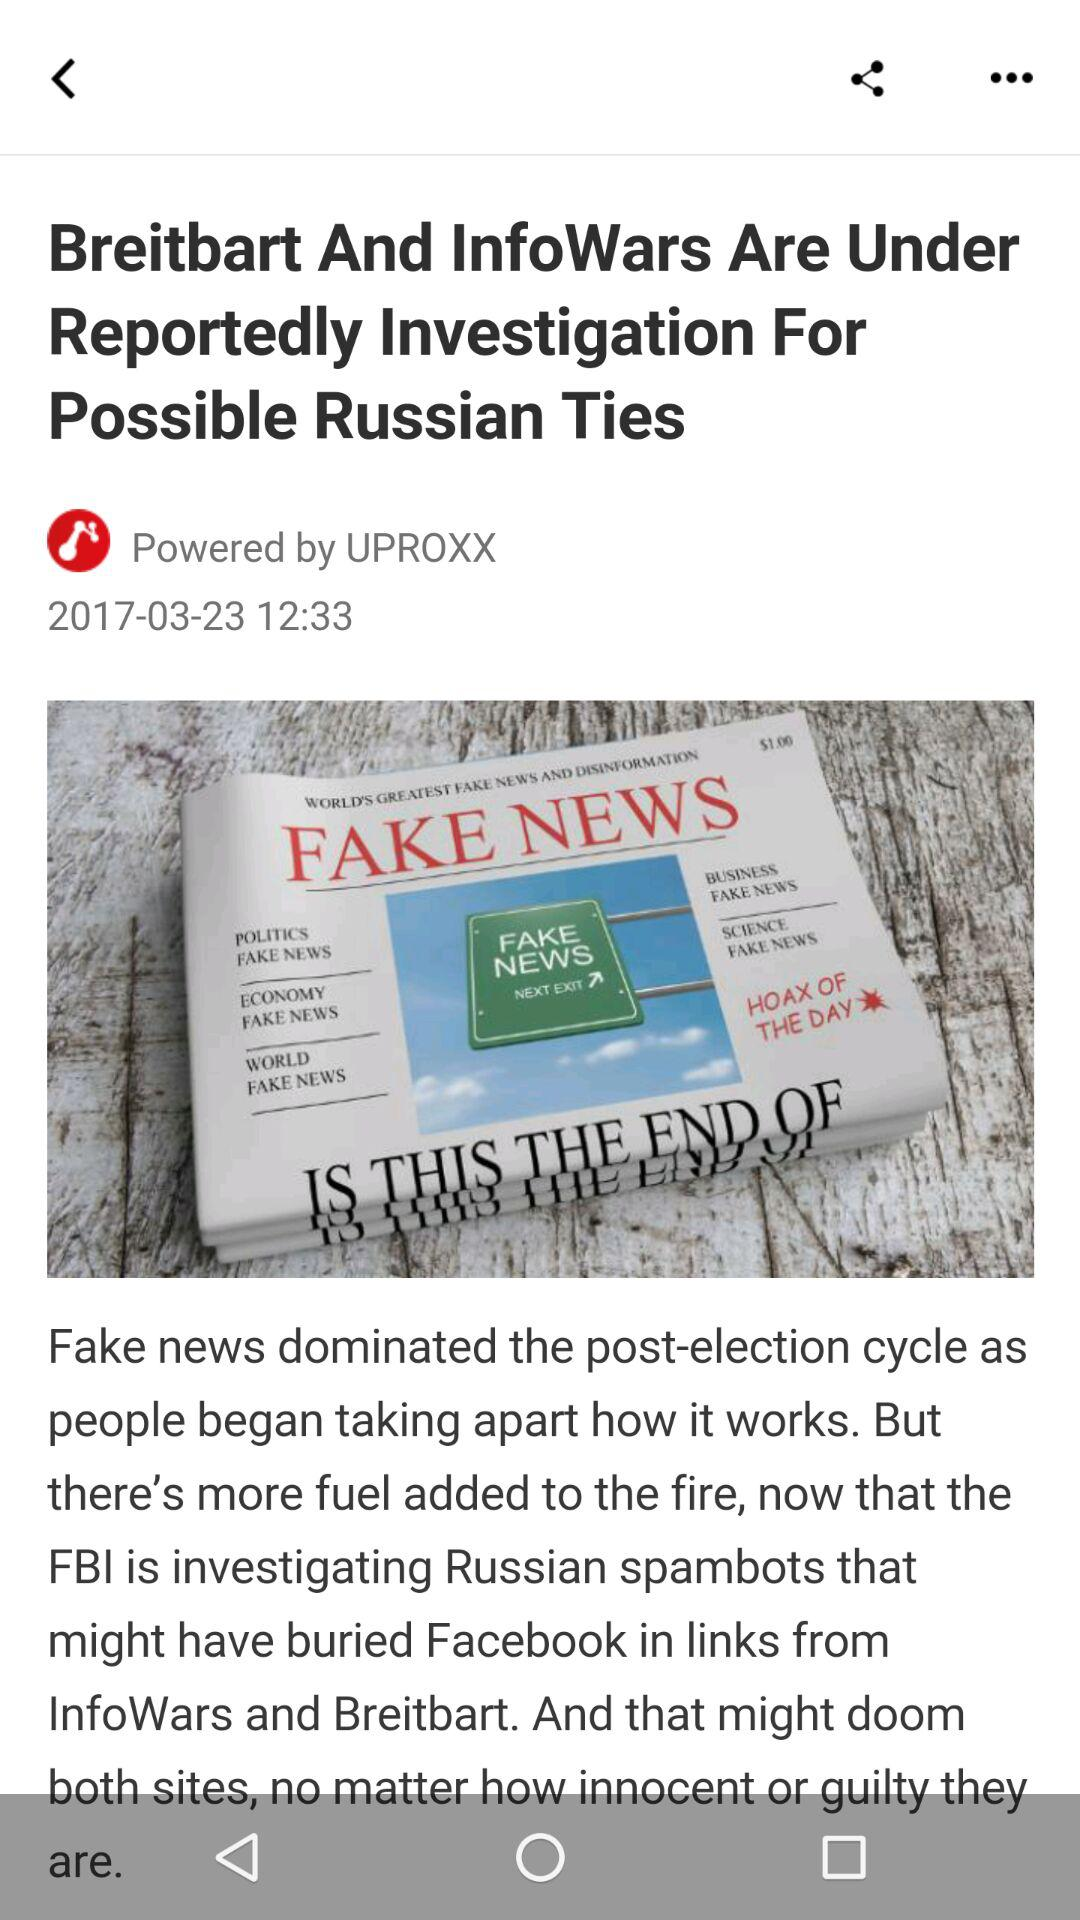What is the publication date? The publication date is March 23, 2017. 